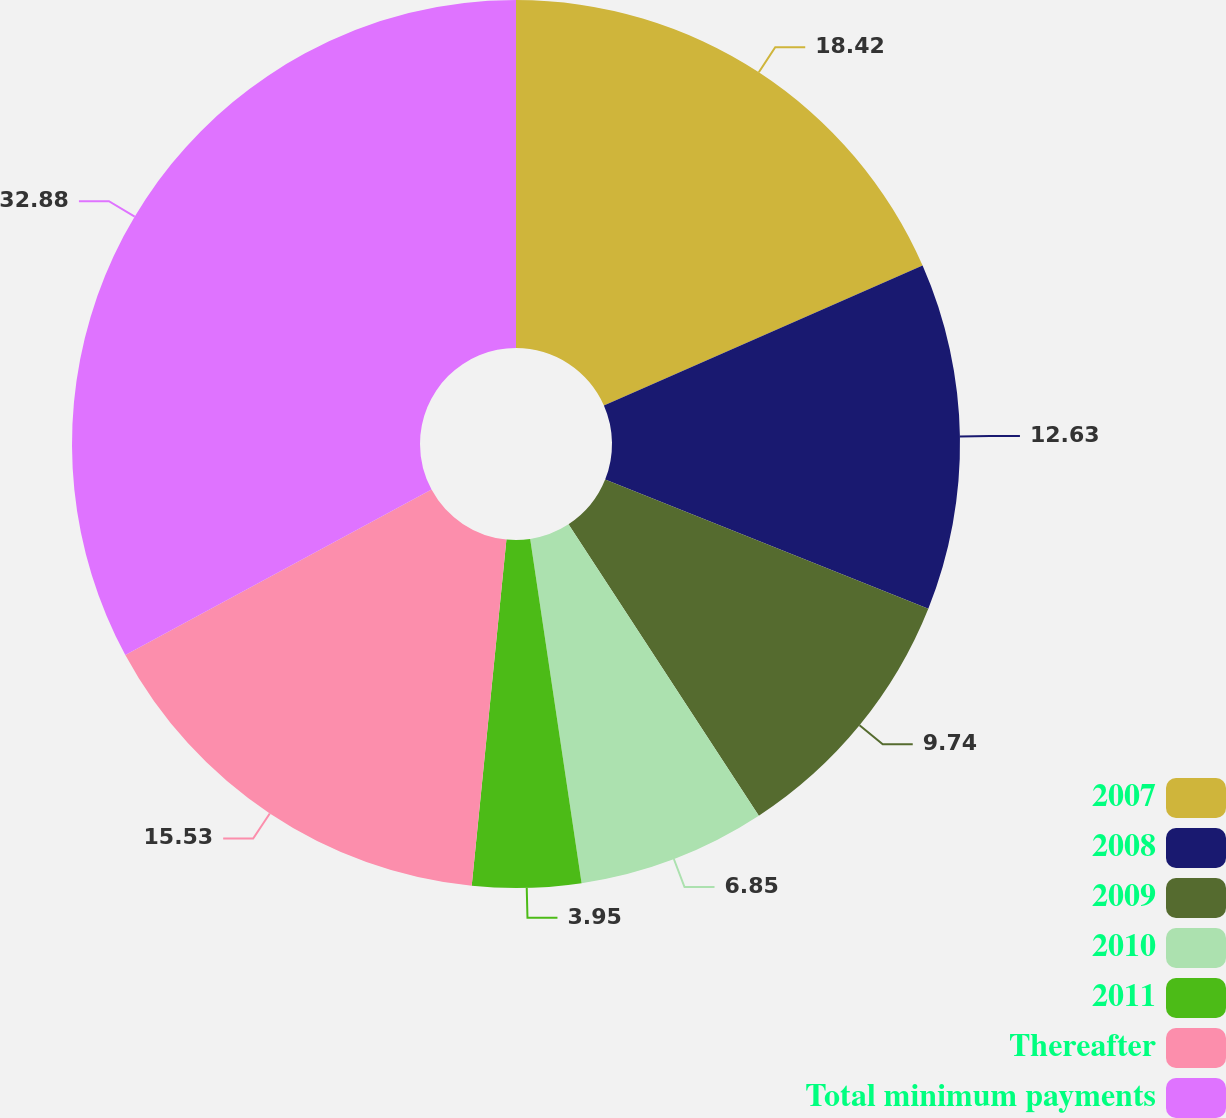<chart> <loc_0><loc_0><loc_500><loc_500><pie_chart><fcel>2007<fcel>2008<fcel>2009<fcel>2010<fcel>2011<fcel>Thereafter<fcel>Total minimum payments<nl><fcel>18.42%<fcel>12.63%<fcel>9.74%<fcel>6.85%<fcel>3.95%<fcel>15.53%<fcel>32.88%<nl></chart> 